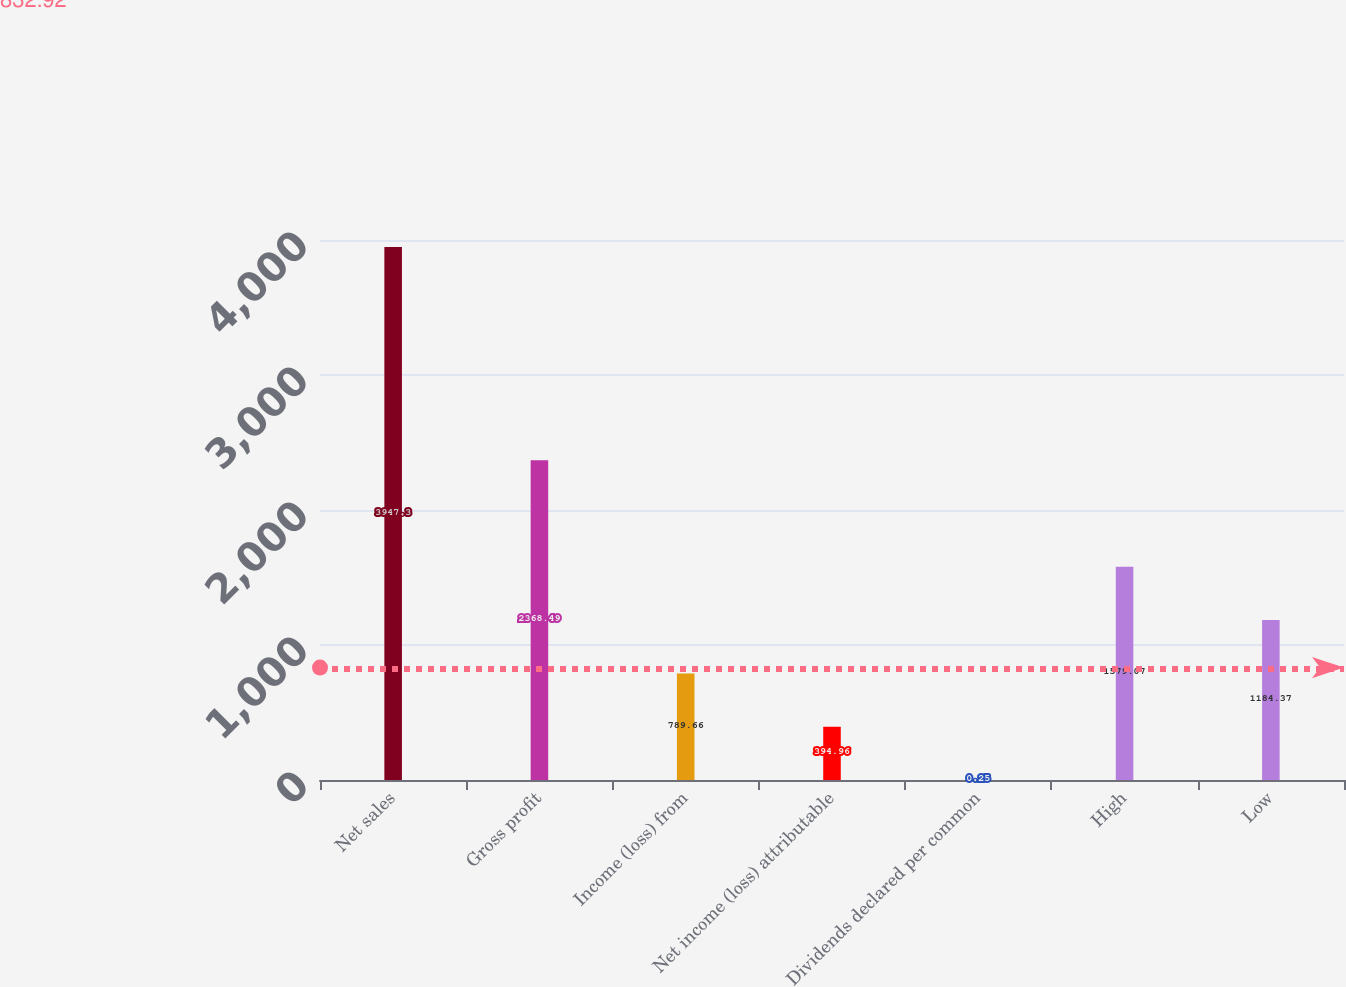Convert chart to OTSL. <chart><loc_0><loc_0><loc_500><loc_500><bar_chart><fcel>Net sales<fcel>Gross profit<fcel>Income (loss) from<fcel>Net income (loss) attributable<fcel>Dividends declared per common<fcel>High<fcel>Low<nl><fcel>3947.3<fcel>2368.49<fcel>789.66<fcel>394.96<fcel>0.25<fcel>1579.07<fcel>1184.37<nl></chart> 